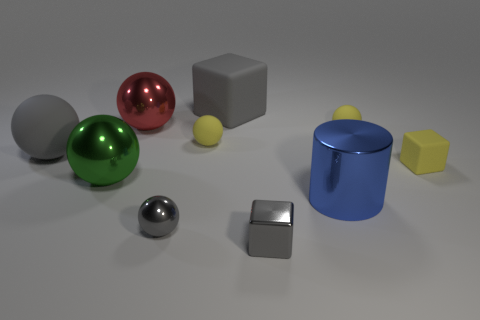Is there anything else that has the same shape as the blue metallic object?
Your answer should be compact. No. Does the small matte thing that is to the left of the large rubber block have the same shape as the yellow rubber thing that is in front of the gray matte ball?
Your answer should be very brief. No. Is there anything else that is the same color as the big cylinder?
Your answer should be very brief. No. What shape is the big red object that is the same material as the big green thing?
Ensure brevity in your answer.  Sphere. There is a small object that is on the right side of the big cube and in front of the green metal sphere; what is its material?
Make the answer very short. Metal. Is there anything else that has the same size as the metallic block?
Make the answer very short. Yes. Does the big cylinder have the same color as the small rubber block?
Your answer should be compact. No. There is a tiny object that is the same color as the small metal ball; what is its shape?
Make the answer very short. Cube. What number of other shiny things are the same shape as the large green metallic thing?
Provide a short and direct response. 2. What size is the yellow cube that is made of the same material as the large gray block?
Give a very brief answer. Small. 